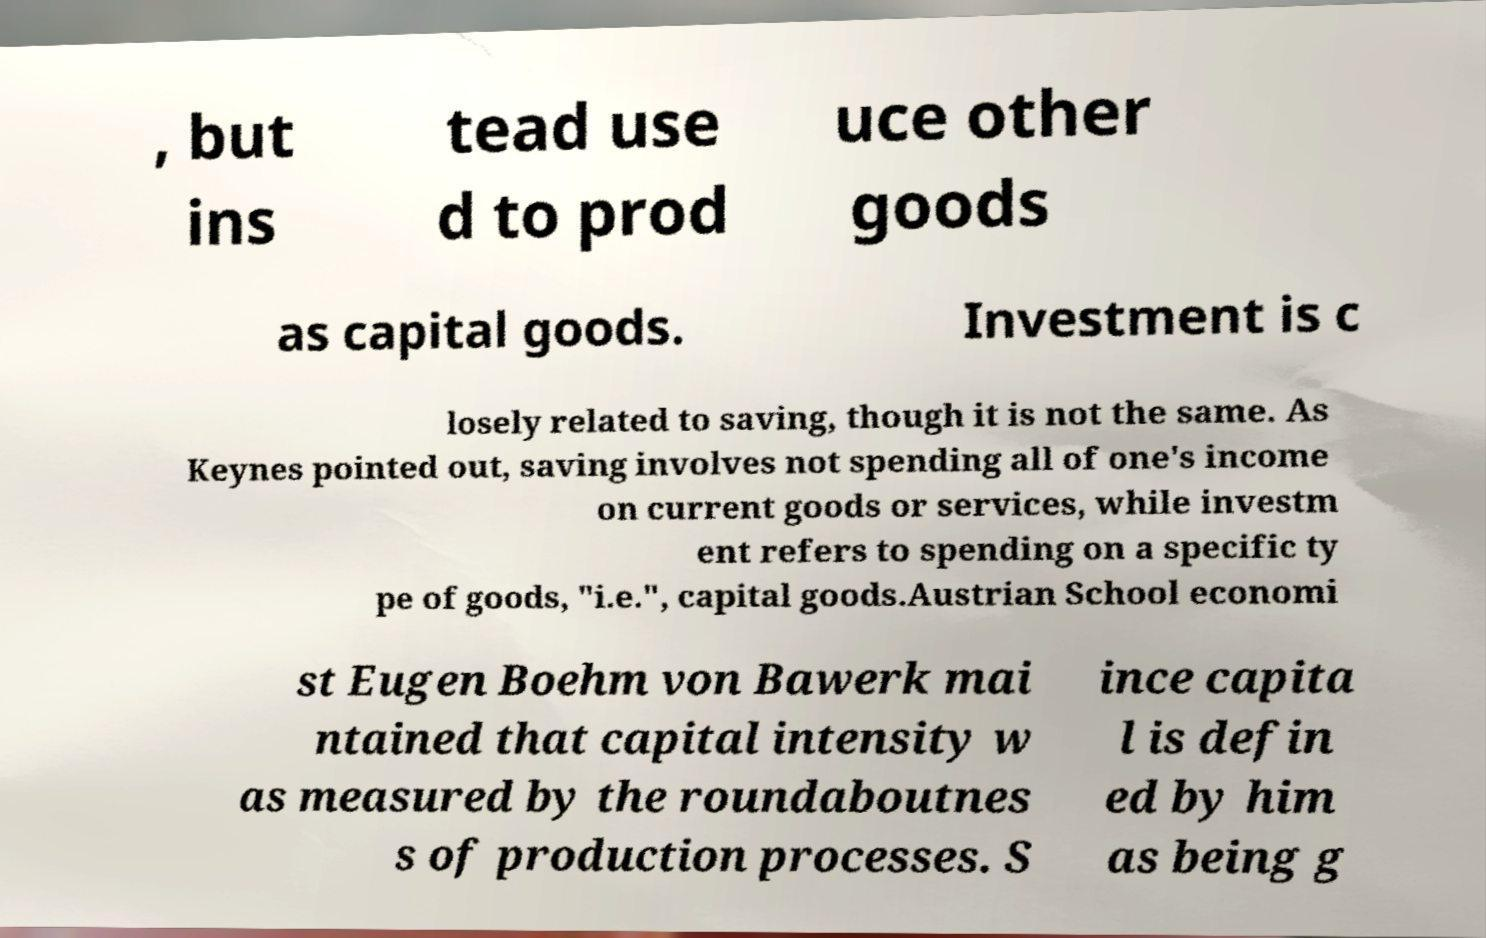Please read and relay the text visible in this image. What does it say? , but ins tead use d to prod uce other goods as capital goods. Investment is c losely related to saving, though it is not the same. As Keynes pointed out, saving involves not spending all of one's income on current goods or services, while investm ent refers to spending on a specific ty pe of goods, "i.e.", capital goods.Austrian School economi st Eugen Boehm von Bawerk mai ntained that capital intensity w as measured by the roundaboutnes s of production processes. S ince capita l is defin ed by him as being g 